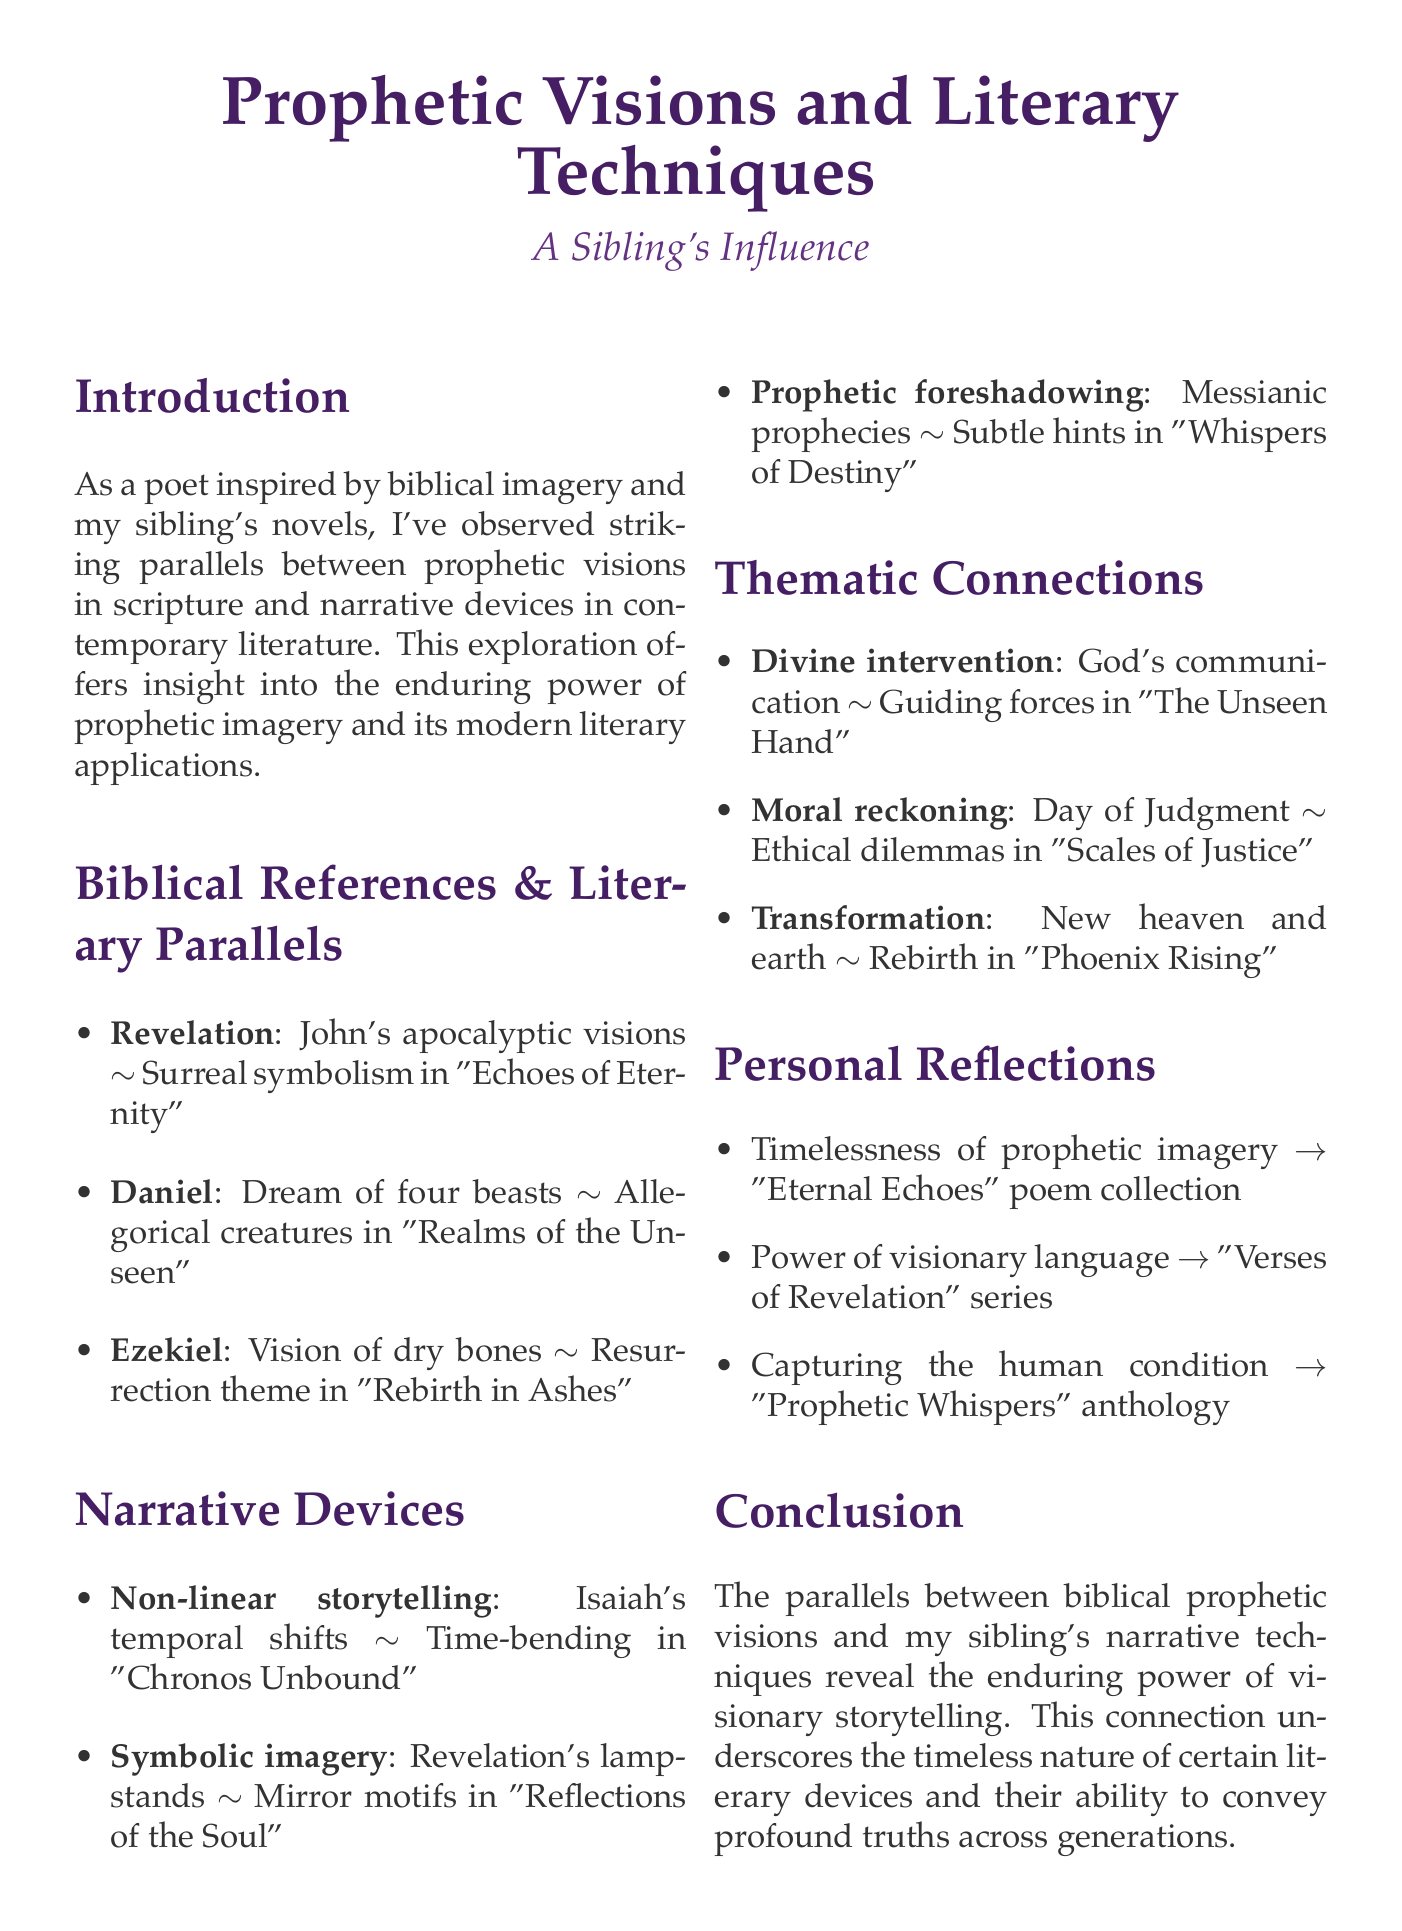What is the title of the memo? The title is given at the beginning of the document, which highlights the main themes discussed.
Answer: Prophetic Visions and Literary Techniques: A Sibling's Influence Who is the author of the memo? The author is mentioned in the introduction as a poet inspired by biblical and literary sources.
Answer: Poet What novel is referenced in connection to John's apocalyptic visions? This information is provided in the section about biblical references and literary parallels, detailing corresponding literary works.
Answer: Echoes of Eternity Which book from the Bible features Daniel's dream of four beasts? This is part of the biblical references that highlights the source of the prophetic vision.
Answer: Book of Daniel What narrative technique is exemplified by the Book of Isaiah? This question pertains to the narrative devices described in the memo, indicating the technique used in both biblical and literary contexts.
Answer: Non-linear storytelling Name one theme mentioned in the thematic connections. The memo lists several themes derived from biblical instances and their literary applications.
Answer: Divine intervention In what work is the resurrection theme explored? This reference is found in the biblical parallels section, linking it to a specific literary work of the author's sibling.
Answer: Rebirth in Ashes What is the significance of the exploration discussed in the introduction? This part of the document explains the importance of the connections made between biblical and literary themes.
Answer: Insight into the enduring power of prophetic imagery What collection incorporates biblical symbols as a poetic application? This refers to the personal reflections section where the author shares insights about their own works.
Answer: Eternal Echoes 